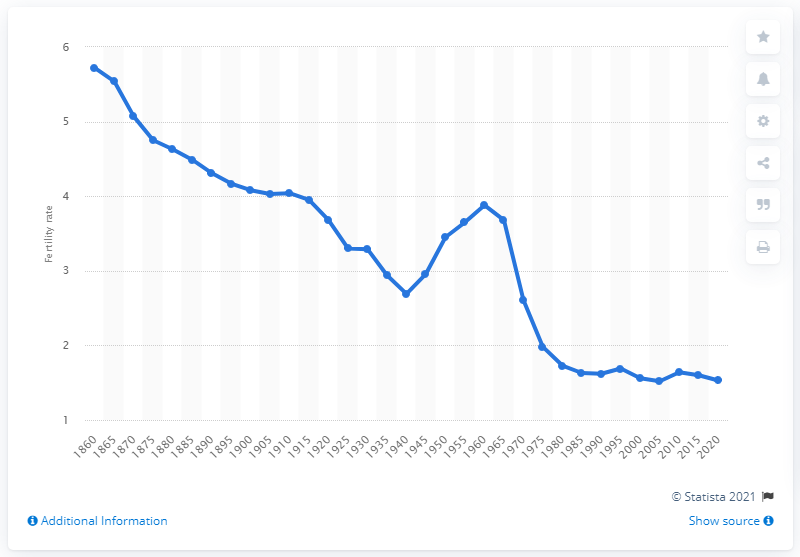Outline some significant characteristics in this image. Canada's fertility rate dropped to 2.7 in 1940. 